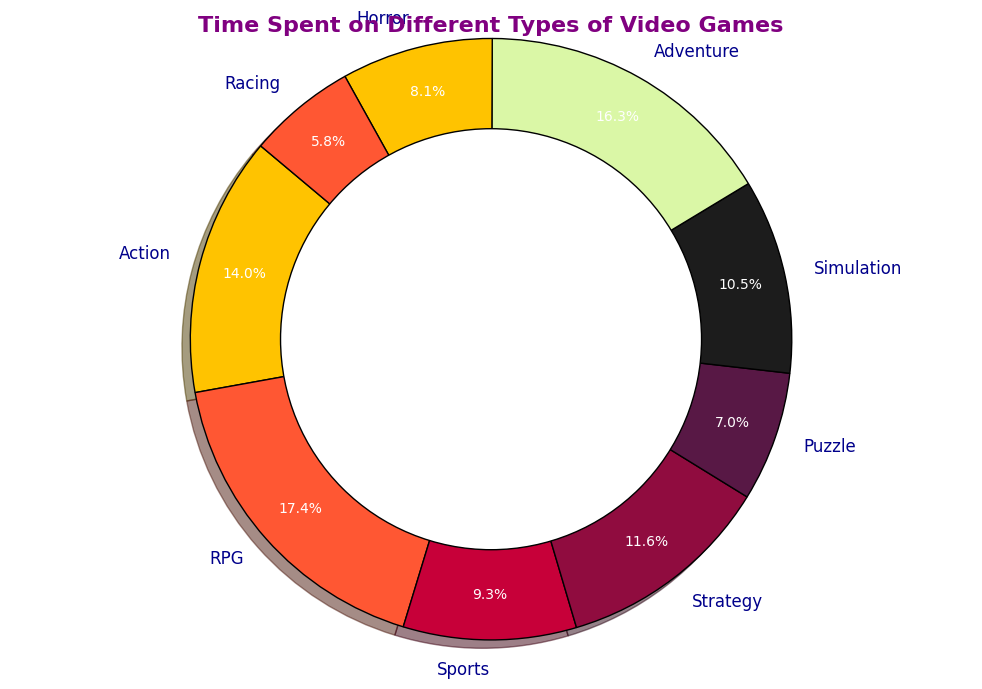What type of game has the highest time spent? The game type with the largest slice in the pie chart represents the highest time spent. Looking at the chart, RPG has the largest slice.
Answer: RPG How much more time is spent on Action games compared to Racing games? Locate the slices for Action and Racing games. Action games correspond to 120 hours, and Racing games correspond to 50 hours. Subtract the Racing game time from the Action game time (120 - 50).
Answer: 70 hours Which two game types have the most similar time spent? Look for slices that have approximately the same size. Adventure (140 hours) and Action (120 hours) have relatively similar values compared to other pairs.
Answer: Adventure and Action What is the total time spent on Puzzle and Horror games combined? Identify the hours for Puzzle (60) and Horror (70) games, then add them together (60 + 70).
Answer: 130 hours Are there more hours spent on Strategy games or Simulation games? Compare the sizes of the slices for Strategy and Simulation. Strategy games correspond to 100 hours, and Simulation games correspond to 90 hours.
Answer: Strategy What percentage of the total time is spent on Sports games? Locate the Sports slice. The wedge shows the percentage directly. Sports games correspond to 8.9% of the total time.
Answer: 8.9% Which game type is represented by a red slice in the chart? Identify the color red in the pie chart. The red slice corresponds to the Action games category.
Answer: Action How many game types have more than 100 hours spent on them? Count the slices corresponding to more than 100 hours. They are Action, RPG, and Adventure.
Answer: 3 What is the difference in percentage between the time spent on Strategy games and Sports games? Find the percentages for both slices from the chart. Strategy is 14.9% and Sports is 11.9%. Calculate the difference in percentage (14.9% - 11.9%).
Answer: 3% Among Puzzle, Simulation, and Horror games, which one has the least time spent? Compare the slices for these game types. Puzzle corresponds to 60 hours, Simulation to 90 hours, and Horror to 70 hours.
Answer: Puzzle 